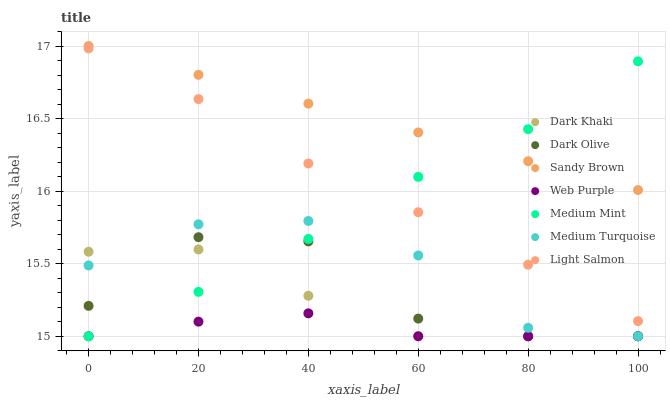Does Web Purple have the minimum area under the curve?
Answer yes or no. Yes. Does Sandy Brown have the maximum area under the curve?
Answer yes or no. Yes. Does Light Salmon have the minimum area under the curve?
Answer yes or no. No. Does Light Salmon have the maximum area under the curve?
Answer yes or no. No. Is Sandy Brown the smoothest?
Answer yes or no. Yes. Is Dark Olive the roughest?
Answer yes or no. Yes. Is Light Salmon the smoothest?
Answer yes or no. No. Is Light Salmon the roughest?
Answer yes or no. No. Does Medium Mint have the lowest value?
Answer yes or no. Yes. Does Light Salmon have the lowest value?
Answer yes or no. No. Does Sandy Brown have the highest value?
Answer yes or no. Yes. Does Light Salmon have the highest value?
Answer yes or no. No. Is Dark Olive less than Sandy Brown?
Answer yes or no. Yes. Is Sandy Brown greater than Light Salmon?
Answer yes or no. Yes. Does Medium Mint intersect Sandy Brown?
Answer yes or no. Yes. Is Medium Mint less than Sandy Brown?
Answer yes or no. No. Is Medium Mint greater than Sandy Brown?
Answer yes or no. No. Does Dark Olive intersect Sandy Brown?
Answer yes or no. No. 